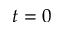Convert formula to latex. <formula><loc_0><loc_0><loc_500><loc_500>t = 0</formula> 